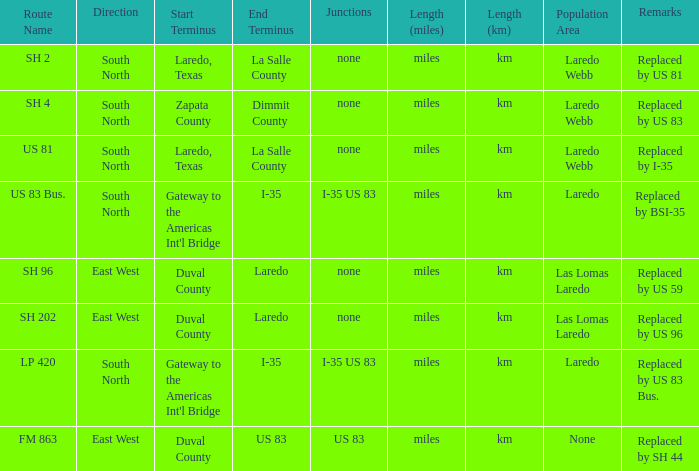Help me parse the entirety of this table. {'header': ['Route Name', 'Direction', 'Start Terminus', 'End Terminus', 'Junctions', 'Length (miles)', 'Length (km)', 'Population Area', 'Remarks'], 'rows': [['SH 2', 'South North', 'Laredo, Texas', 'La Salle County', 'none', 'miles', 'km', 'Laredo Webb', 'Replaced by US 81'], ['SH 4', 'South North', 'Zapata County', 'Dimmit County', 'none', 'miles', 'km', 'Laredo Webb', 'Replaced by US 83'], ['US 81', 'South North', 'Laredo, Texas', 'La Salle County', 'none', 'miles', 'km', 'Laredo Webb', 'Replaced by I-35'], ['US 83 Bus.', 'South North', "Gateway to the Americas Int'l Bridge", 'I-35', 'I-35 US 83', 'miles', 'km', 'Laredo', 'Replaced by BSI-35'], ['SH 96', 'East West', 'Duval County', 'Laredo', 'none', 'miles', 'km', 'Las Lomas Laredo', 'Replaced by US 59'], ['SH 202', 'East West', 'Duval County', 'Laredo', 'none', 'miles', 'km', 'Las Lomas Laredo', 'Replaced by US 96'], ['LP 420', 'South North', "Gateway to the Americas Int'l Bridge", 'I-35', 'I-35 US 83', 'miles', 'km', 'Laredo', 'Replaced by US 83 Bus.'], ['FM 863', 'East West', 'Duval County', 'US 83', 'US 83', 'miles', 'km', 'None', 'Replaced by SH 44']]} Which routes have  "replaced by US 81" listed in their remarks section? SH 2. 